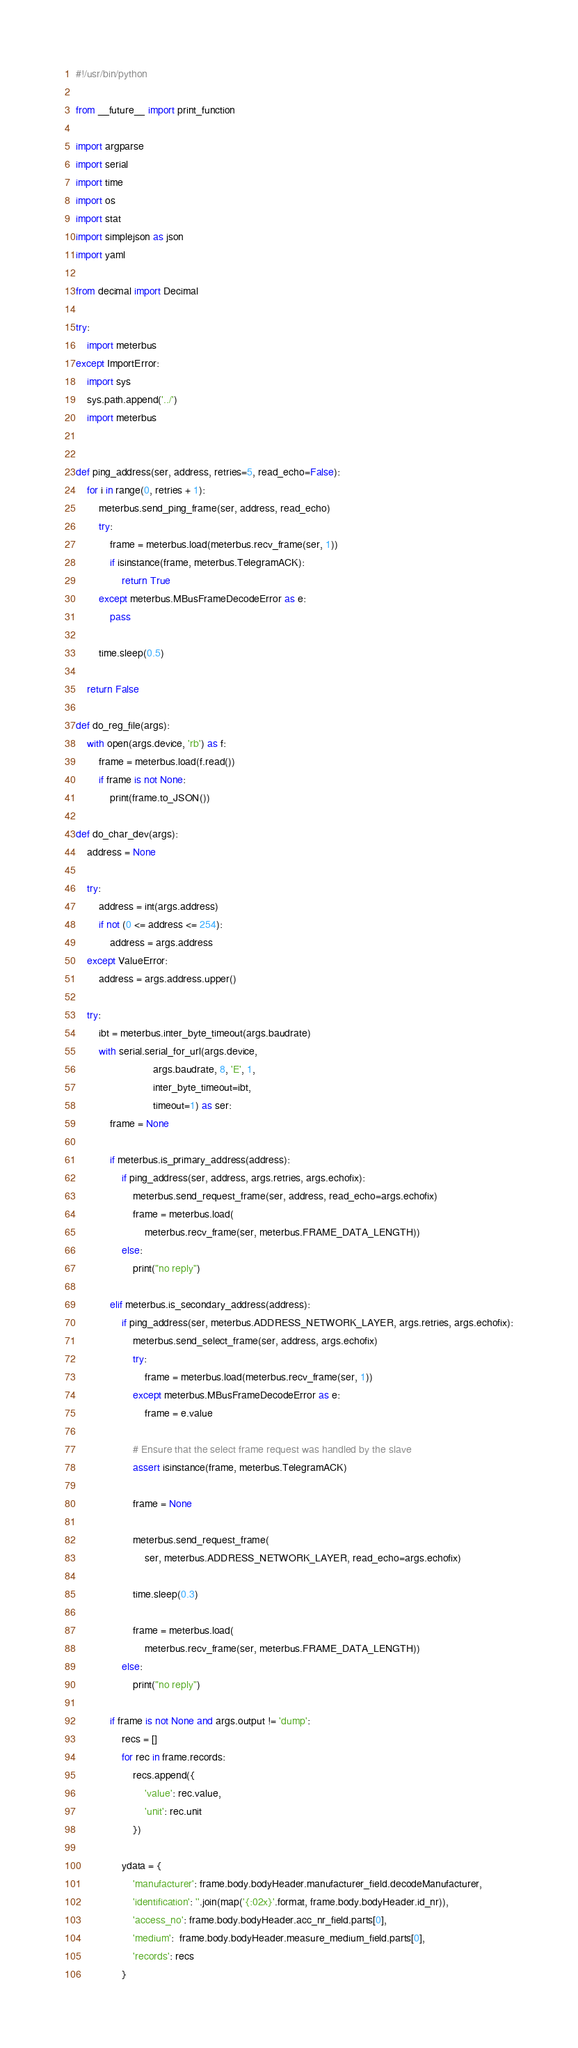Convert code to text. <code><loc_0><loc_0><loc_500><loc_500><_Python_>#!/usr/bin/python

from __future__ import print_function

import argparse
import serial
import time
import os
import stat
import simplejson as json
import yaml

from decimal import Decimal

try:
    import meterbus
except ImportError:
    import sys
    sys.path.append('../')
    import meterbus


def ping_address(ser, address, retries=5, read_echo=False):
    for i in range(0, retries + 1):
        meterbus.send_ping_frame(ser, address, read_echo)
        try:
            frame = meterbus.load(meterbus.recv_frame(ser, 1))
            if isinstance(frame, meterbus.TelegramACK):
                return True
        except meterbus.MBusFrameDecodeError as e:
            pass

        time.sleep(0.5)

    return False

def do_reg_file(args):
    with open(args.device, 'rb') as f:
        frame = meterbus.load(f.read())
        if frame is not None:
            print(frame.to_JSON())

def do_char_dev(args):
    address = None

    try:
        address = int(args.address)
        if not (0 <= address <= 254):
            address = args.address
    except ValueError:
        address = args.address.upper()

    try:
        ibt = meterbus.inter_byte_timeout(args.baudrate)
        with serial.serial_for_url(args.device,
                           args.baudrate, 8, 'E', 1,
                           inter_byte_timeout=ibt,
                           timeout=1) as ser:
            frame = None

            if meterbus.is_primary_address(address):
                if ping_address(ser, address, args.retries, args.echofix):
                    meterbus.send_request_frame(ser, address, read_echo=args.echofix)
                    frame = meterbus.load(
                        meterbus.recv_frame(ser, meterbus.FRAME_DATA_LENGTH))
                else:
                    print("no reply")

            elif meterbus.is_secondary_address(address):
                if ping_address(ser, meterbus.ADDRESS_NETWORK_LAYER, args.retries, args.echofix):
                    meterbus.send_select_frame(ser, address, args.echofix)
                    try:
                        frame = meterbus.load(meterbus.recv_frame(ser, 1))
                    except meterbus.MBusFrameDecodeError as e:
                        frame = e.value

                    # Ensure that the select frame request was handled by the slave
                    assert isinstance(frame, meterbus.TelegramACK)

                    frame = None

                    meterbus.send_request_frame(
                        ser, meterbus.ADDRESS_NETWORK_LAYER, read_echo=args.echofix)

                    time.sleep(0.3)

                    frame = meterbus.load(
                        meterbus.recv_frame(ser, meterbus.FRAME_DATA_LENGTH))
                else:
                    print("no reply")

            if frame is not None and args.output != 'dump':
                recs = []
                for rec in frame.records:
                    recs.append({
                        'value': rec.value,
                        'unit': rec.unit
                    })

                ydata = {
                    'manufacturer': frame.body.bodyHeader.manufacturer_field.decodeManufacturer,
                    'identification': ''.join(map('{:02x}'.format, frame.body.bodyHeader.id_nr)),
                    'access_no': frame.body.bodyHeader.acc_nr_field.parts[0],
                    'medium':  frame.body.bodyHeader.measure_medium_field.parts[0],
                    'records': recs
                }
</code> 